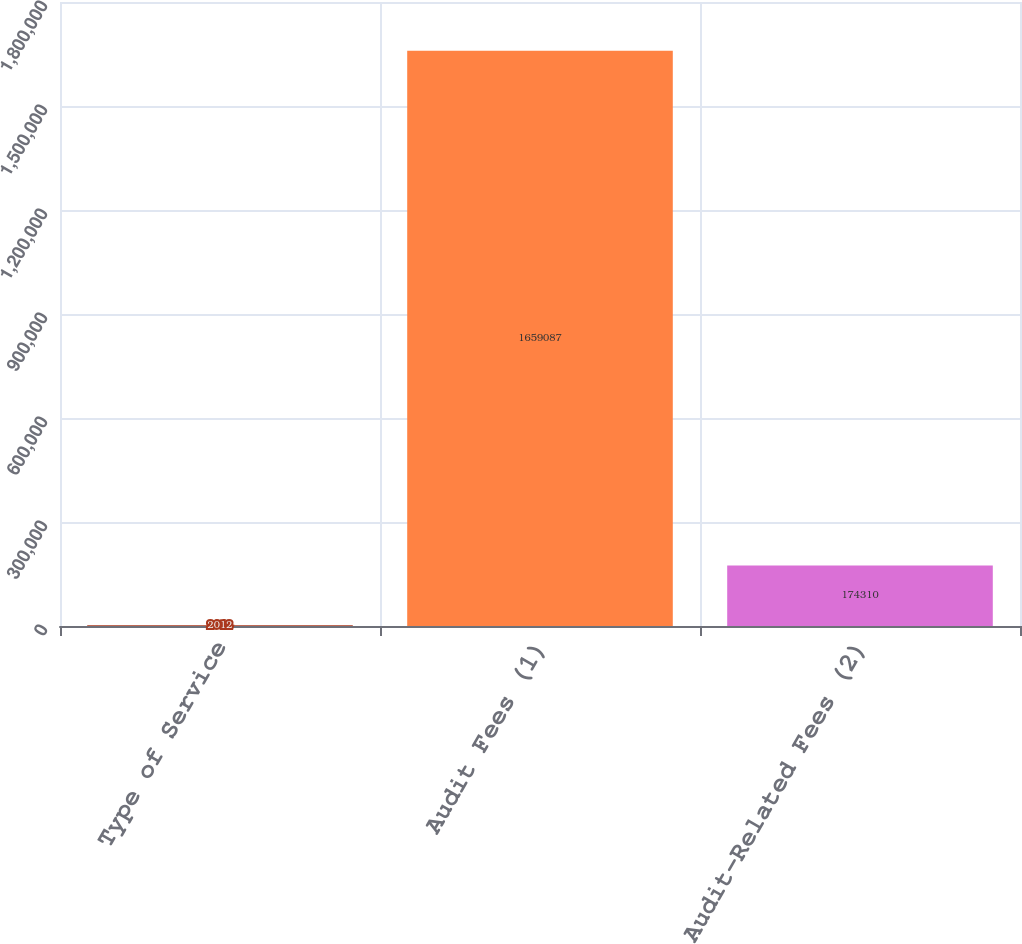Convert chart. <chart><loc_0><loc_0><loc_500><loc_500><bar_chart><fcel>Type of Service<fcel>Audit Fees (1)<fcel>Audit-Related Fees (2)<nl><fcel>2012<fcel>1.65909e+06<fcel>174310<nl></chart> 